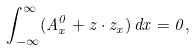Convert formula to latex. <formula><loc_0><loc_0><loc_500><loc_500>\int _ { - \infty } ^ { \infty } ( A ^ { 0 } _ { x } + z \cdot z _ { x } ) \, d x = 0 ,</formula> 